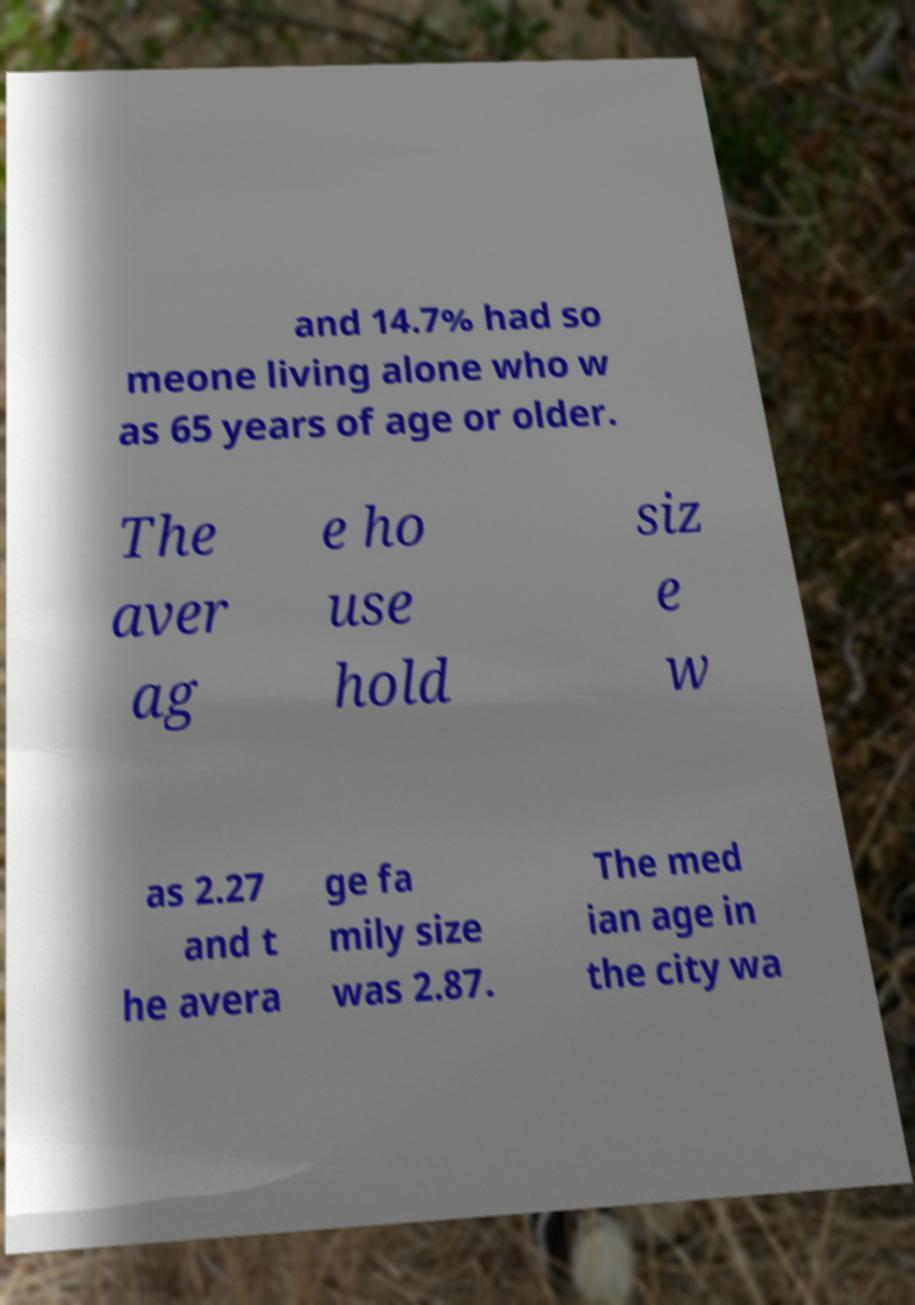Please read and relay the text visible in this image. What does it say? and 14.7% had so meone living alone who w as 65 years of age or older. The aver ag e ho use hold siz e w as 2.27 and t he avera ge fa mily size was 2.87. The med ian age in the city wa 